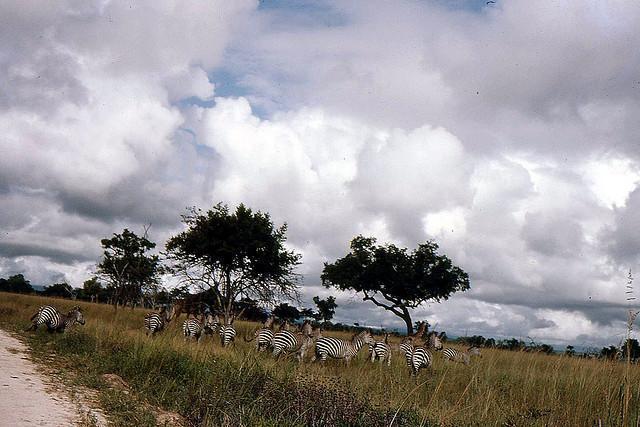The clouds in the sky depict that a is coming?
Indicate the correct choice and explain in the format: 'Answer: answer
Rationale: rationale.'
Options: Earthquake, hurricane, snowstorm, storm. Answer: storm.
Rationale: Clouds have nothing to do with earthquakes. these animals are zebras that live in an area that is not affected by snow or hurricanes. 